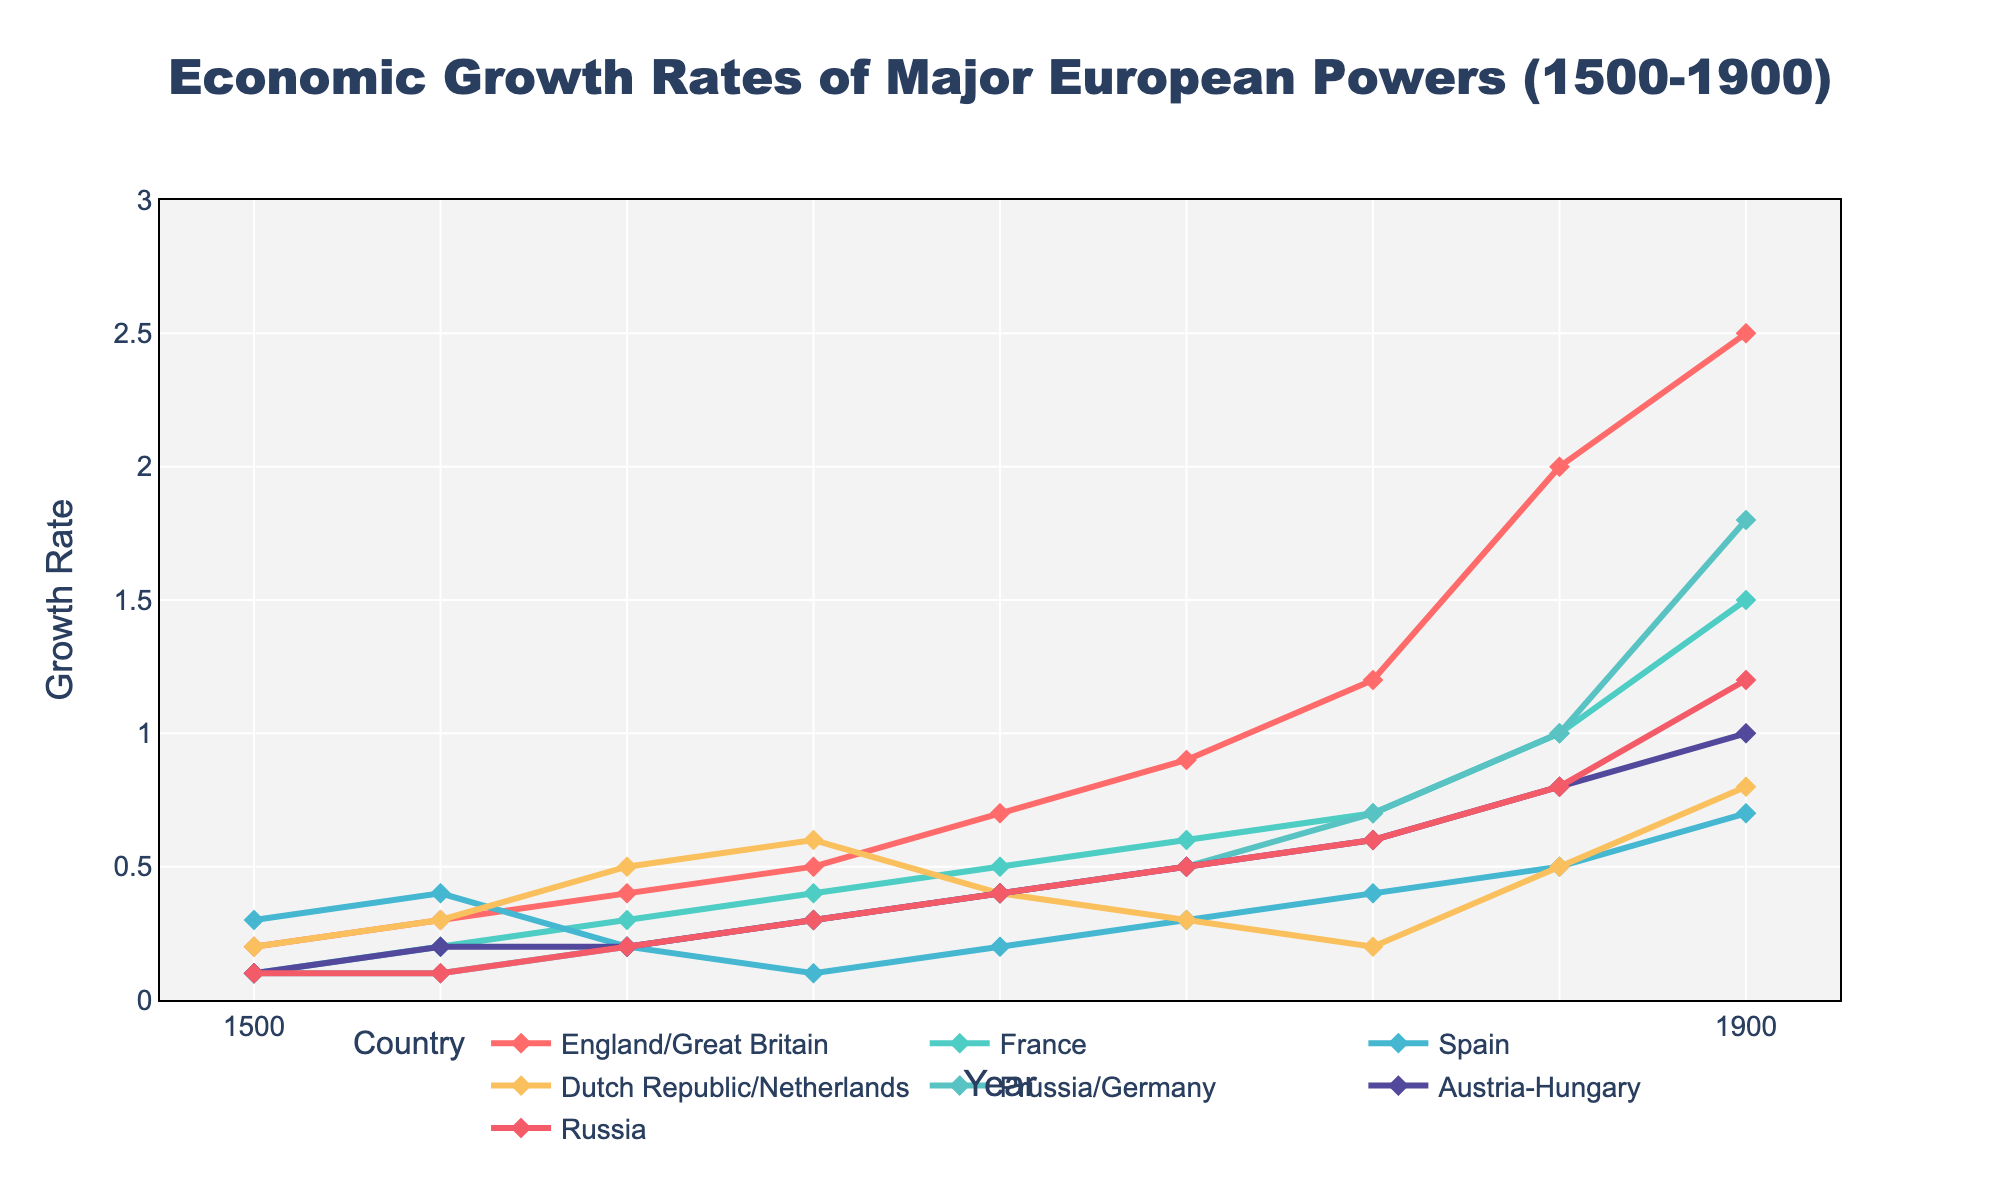Which country had the highest economic growth rate in 1700? To determine the country with the highest economic growth rate in 1700, look at the y-axis values for the year 1700. The country with the highest value is England/Great Britain at 0.7.
Answer: England/Great Britain Which two countries had equal growth rates in 1800? Identify the countries whose growth rates match for the year 1800 by comparing the y-axis values. For 1800, Austria-Hungary and Russia both have a growth rate of 0.6.
Answer: Austria-Hungary and Russia Between 1600 and 1650, which country experienced the largest increase in growth rate? Compare the growth rates between 1600 and 1650 for each country and find the difference. The largest increase is found for the Dutch Republic/Netherlands, increasing from 0.5 to 0.6, a difference of 0.5.
Answer: Dutch Republic/Netherlands Which country shows the most consistent growth rate from 1500 to 1900? To determine which country shows consistent growth, look for the one with the steadiest line. England/Great Britain shows consistent increases over time with few fluctuations.
Answer: England/Great Britain What is the growth rate difference between Germany and France in 1850? Locate the growth rates for both Germany and France in 1850, then compute the difference. Germany's growth rate is 1.0 and France's is 1.0 - 0.5 = 0.5, resulting in a difference of 0.5.
Answer: 0.5 How did Spain's growth rate change from 1500 to 1900? Compare Spain's growth rate in 1500 (0.3) with that in 1900 (0.7). Subtract the initial value from the latter value for the change: 0.7 - 0.3 = 0.4.
Answer: Increased by 0.4 Which country had the highest growth rate in 1800, and what was it? Check each country's growth rate in the year 1800, and the highest is noted for England/Great Britain with a rate of 1.2.
Answer: England/Great Britain with 1.2 Was Russia's economic growth rate in 1900 greater than, less than, or equal to Austria-Hungary's? Compare the values in 1900 for Russia (1.2) and Austria-Hungary (1.0). Russia's growth rate is greater.
Answer: Greater Which country had the slowest growth rate in 1650? Identify the country with the lowest growth rate in 1650. Spain has the lowest growth rate at 0.1.
Answer: Spain 